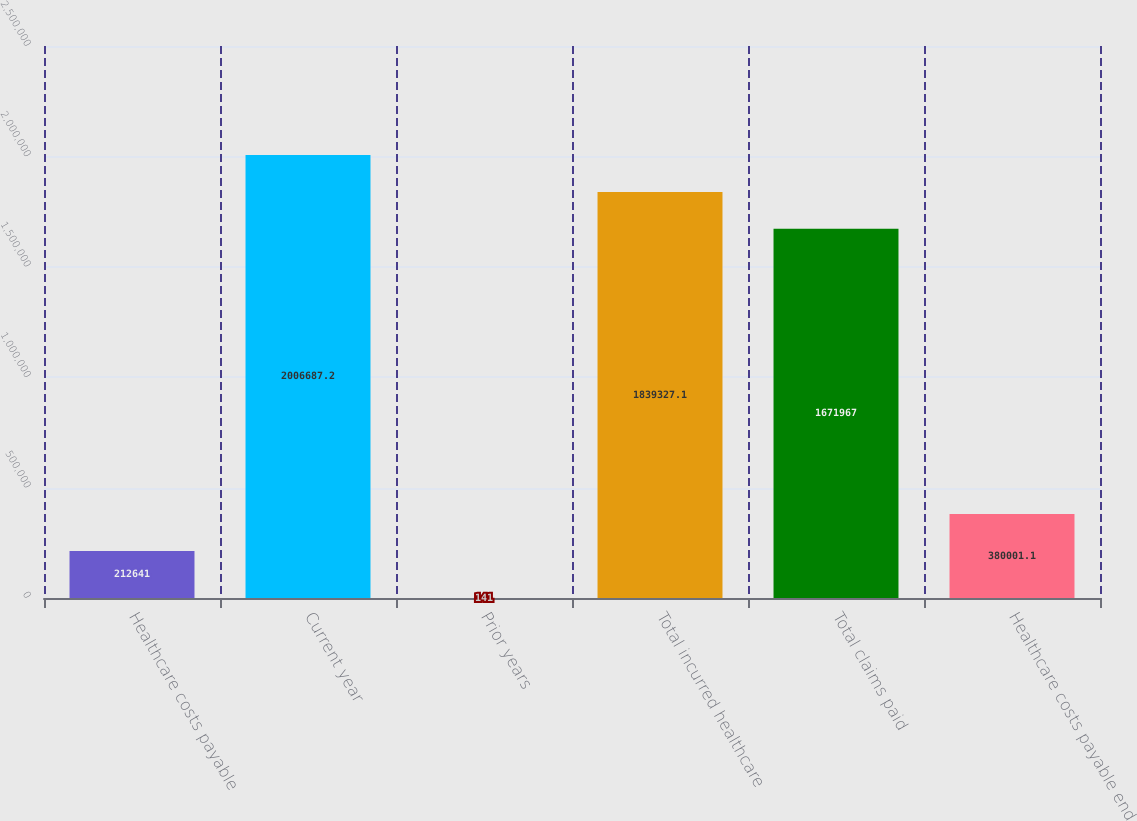Convert chart. <chart><loc_0><loc_0><loc_500><loc_500><bar_chart><fcel>Healthcare costs payable<fcel>Current year<fcel>Prior years<fcel>Total incurred healthcare<fcel>Total claims paid<fcel>Healthcare costs payable end<nl><fcel>212641<fcel>2.00669e+06<fcel>141<fcel>1.83933e+06<fcel>1.67197e+06<fcel>380001<nl></chart> 